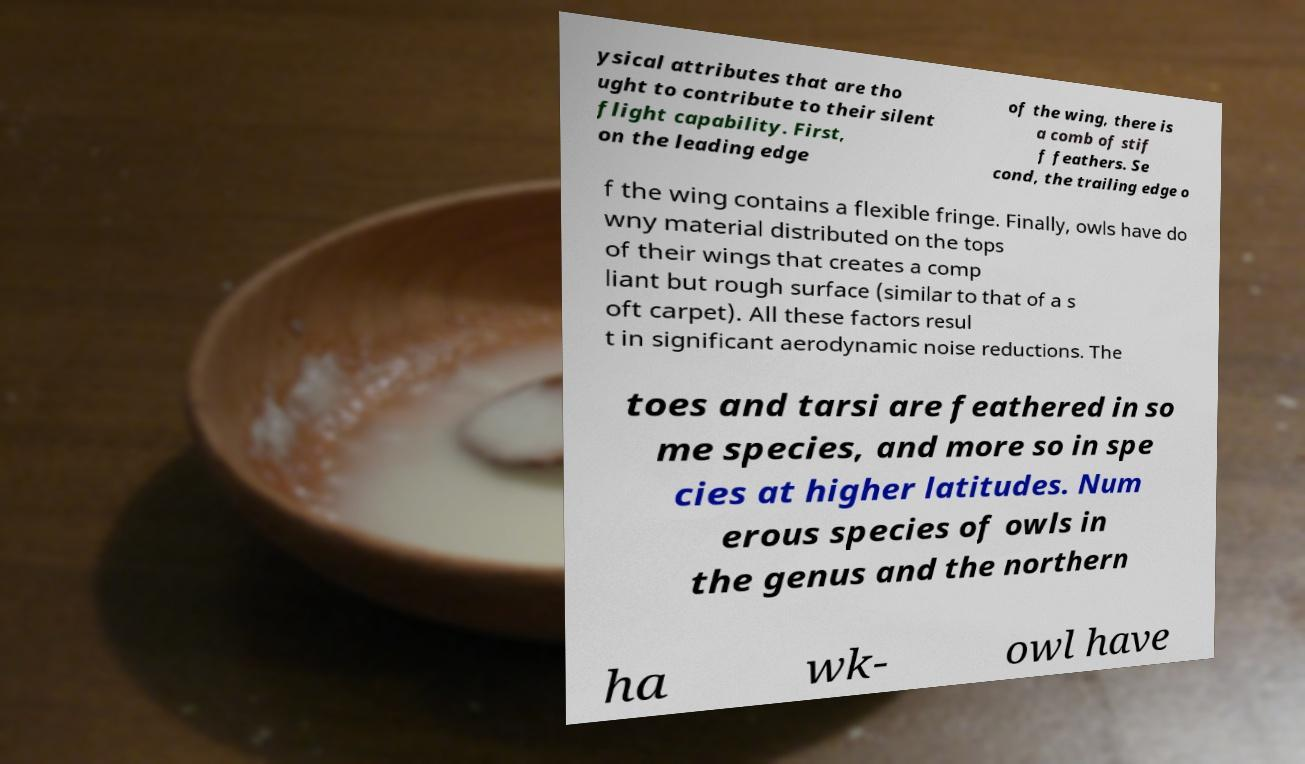Could you extract and type out the text from this image? ysical attributes that are tho ught to contribute to their silent flight capability. First, on the leading edge of the wing, there is a comb of stif f feathers. Se cond, the trailing edge o f the wing contains a flexible fringe. Finally, owls have do wny material distributed on the tops of their wings that creates a comp liant but rough surface (similar to that of a s oft carpet). All these factors resul t in significant aerodynamic noise reductions. The toes and tarsi are feathered in so me species, and more so in spe cies at higher latitudes. Num erous species of owls in the genus and the northern ha wk- owl have 